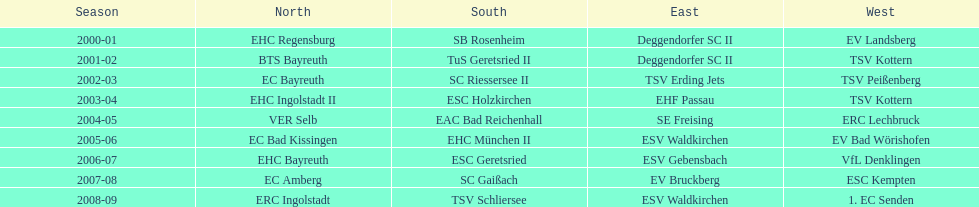The latest team to triumph in the west? 1. EC Senden. 